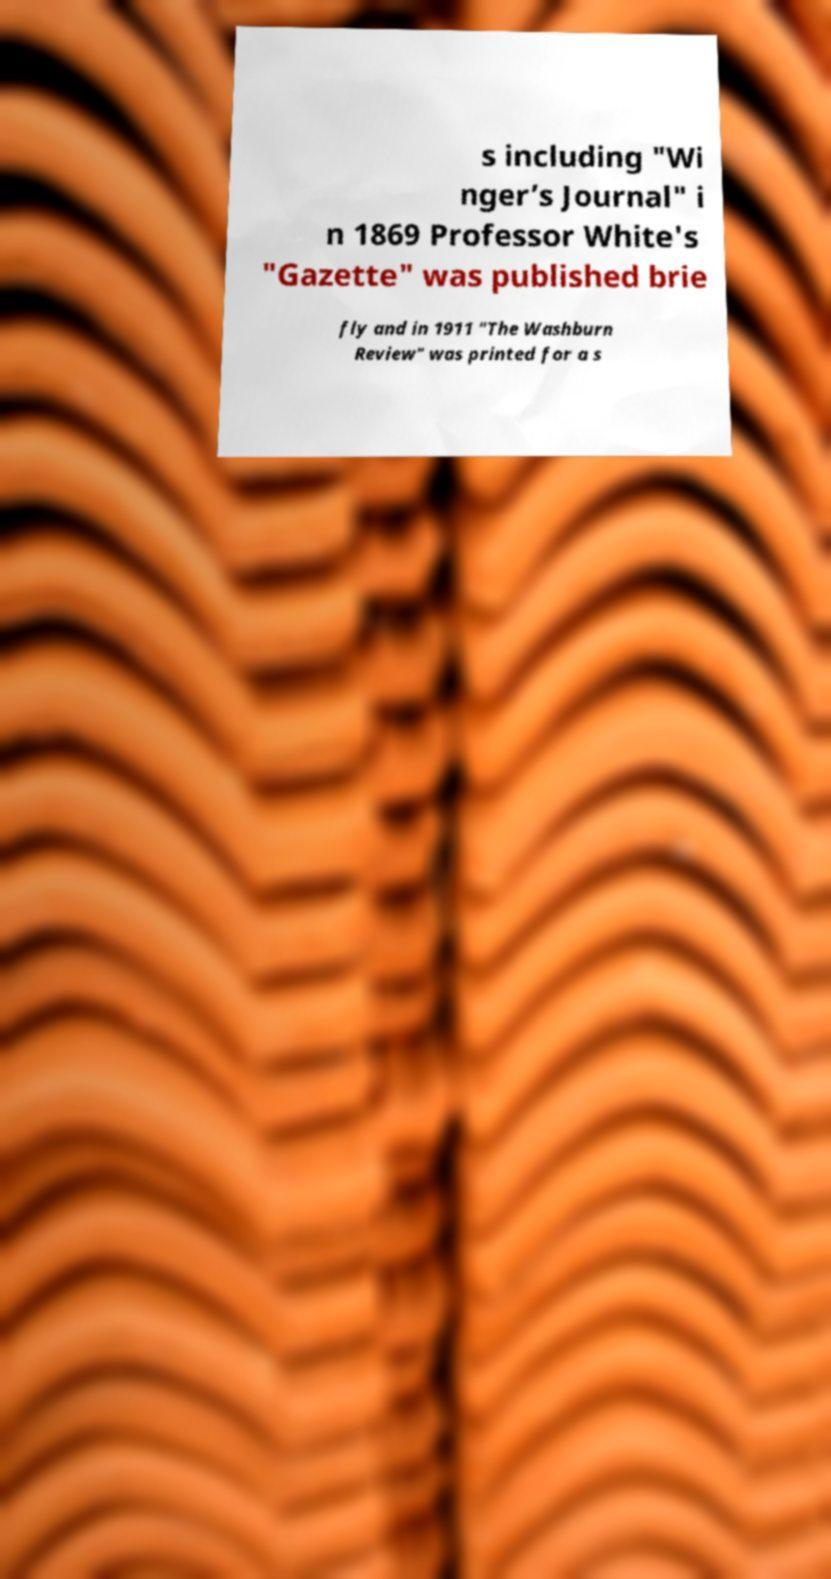For documentation purposes, I need the text within this image transcribed. Could you provide that? s including "Wi nger’s Journal" i n 1869 Professor White's "Gazette" was published brie fly and in 1911 "The Washburn Review" was printed for a s 